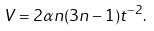Convert formula to latex. <formula><loc_0><loc_0><loc_500><loc_500>V = 2 \alpha n ( 3 n - 1 ) t ^ { - 2 } .</formula> 